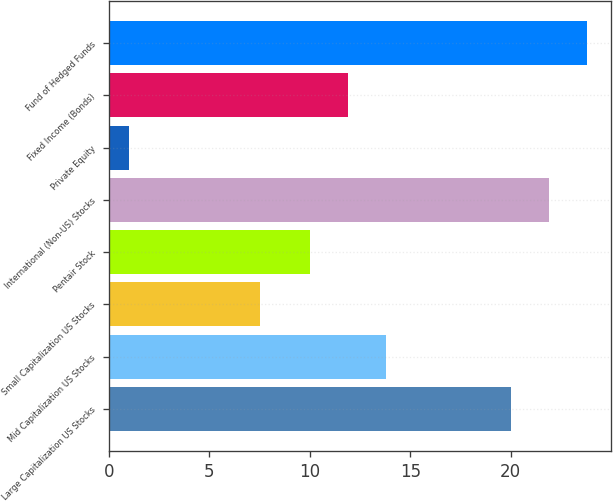Convert chart to OTSL. <chart><loc_0><loc_0><loc_500><loc_500><bar_chart><fcel>Large Capitalization US Stocks<fcel>Mid Capitalization US Stocks<fcel>Small Capitalization US Stocks<fcel>Pentair Stock<fcel>International (Non-US) Stocks<fcel>Private Equity<fcel>Fixed Income (Bonds)<fcel>Fund of Hedged Funds<nl><fcel>20<fcel>13.8<fcel>7.5<fcel>10<fcel>21.9<fcel>1<fcel>11.9<fcel>23.8<nl></chart> 